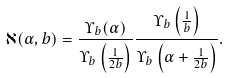<formula> <loc_0><loc_0><loc_500><loc_500>\aleph ( \alpha , b ) = \frac { \Upsilon _ { b } ( \alpha ) } { \Upsilon _ { b } \left ( \frac { 1 } { 2 b } \right ) } \frac { \Upsilon _ { b } \left ( \frac { 1 } { b } \right ) } { \Upsilon _ { b } \left ( \alpha + \frac { 1 } { 2 b } \right ) } .</formula> 